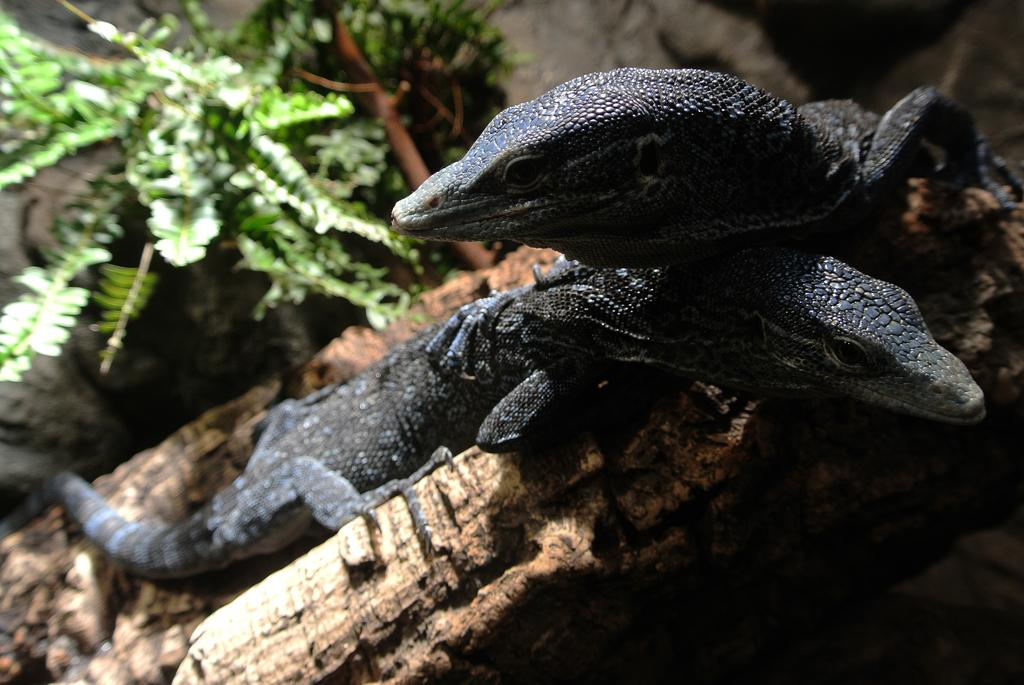What type of animals are in the front of the image? There are two reptiles in the front of the image. What can be seen in the background of the image? There is a plant in the background of the image. What is located at the bottom of the image? There appears to be a rock at the bottom of the image. Who is the owner of the shop in the image? There is no shop present in the image. 